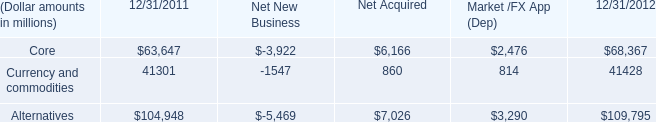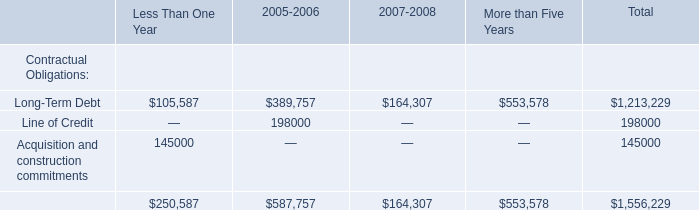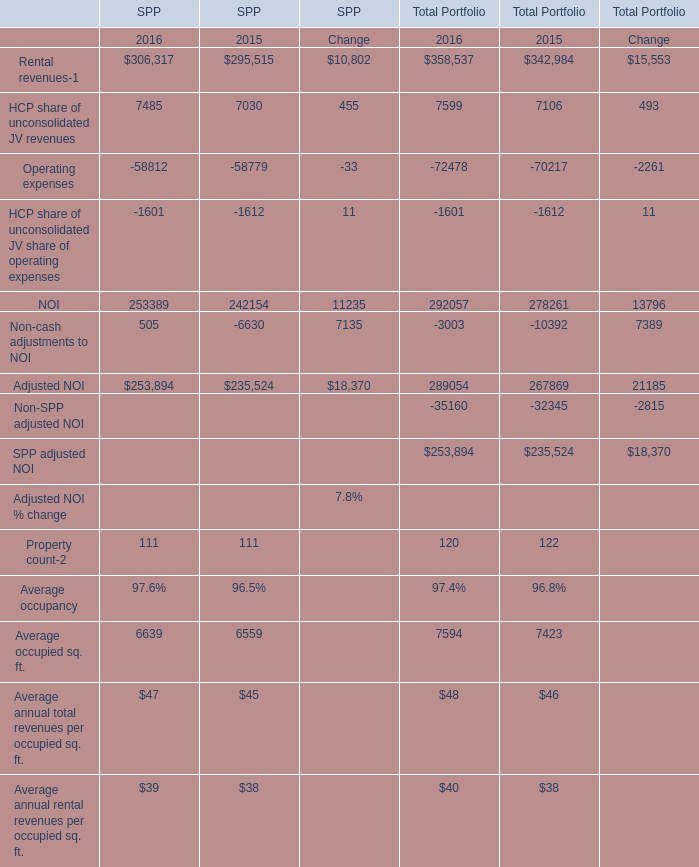What's the average of Acquisition and construction commitments of Less Than One Year, and Alternatives of Net New Business ? 
Computations: ((145000.0 + 5469.0) / 2)
Answer: 75234.5. 